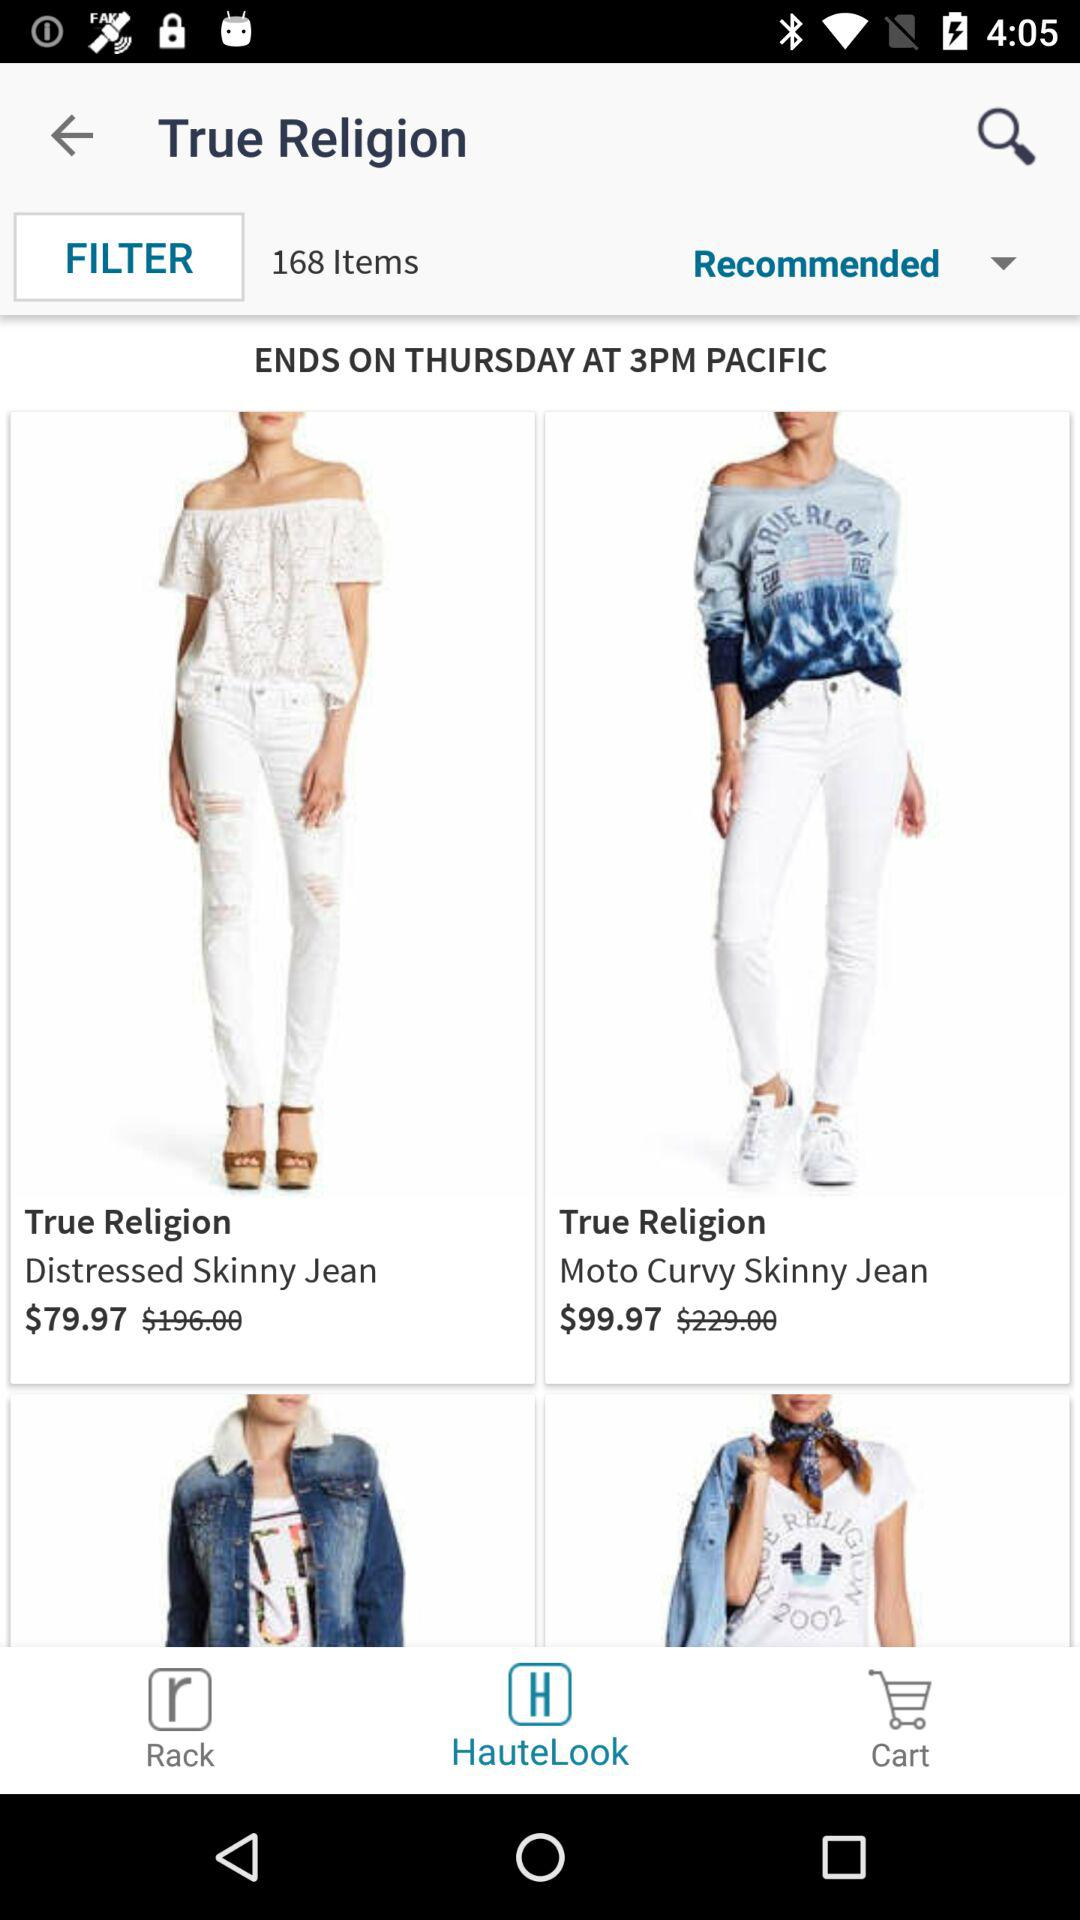What is the price of "Moto Curvy Skinny Jean"? The price is $99.97. 